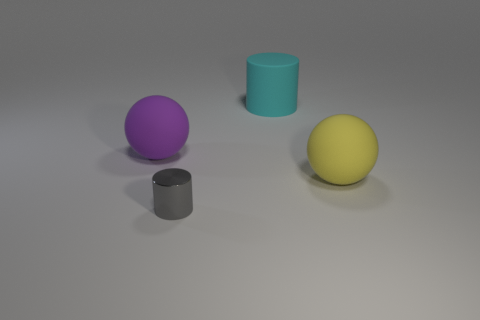Add 2 large metal spheres. How many objects exist? 6 Subtract all yellow spheres. Subtract all brown cylinders. How many spheres are left? 1 Subtract all gray cubes. How many gray cylinders are left? 1 Subtract all purple cubes. Subtract all small shiny cylinders. How many objects are left? 3 Add 2 big purple objects. How many big purple objects are left? 3 Add 1 cyan matte cylinders. How many cyan matte cylinders exist? 2 Subtract all gray cylinders. How many cylinders are left? 1 Subtract 0 cyan blocks. How many objects are left? 4 Subtract 1 cylinders. How many cylinders are left? 1 